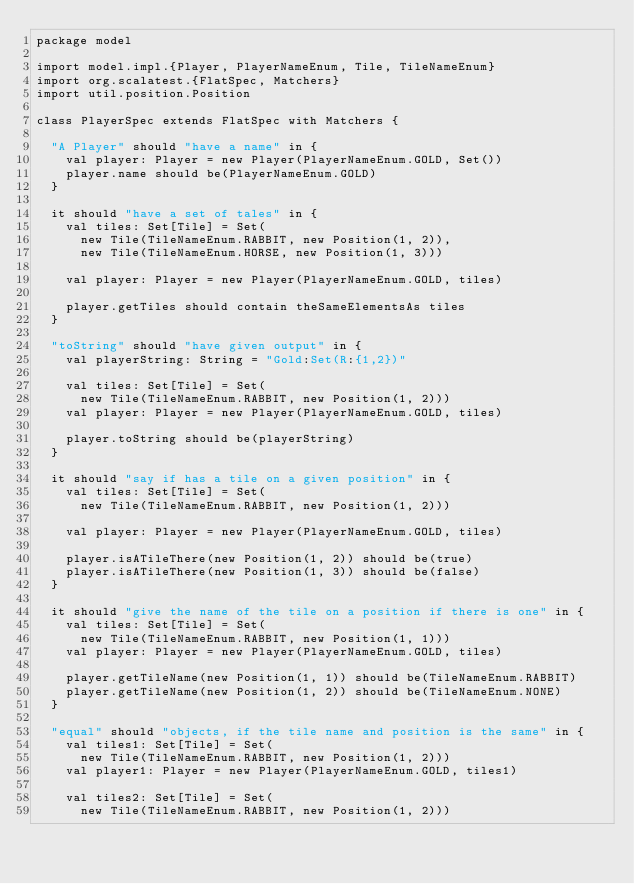Convert code to text. <code><loc_0><loc_0><loc_500><loc_500><_Scala_>package model

import model.impl.{Player, PlayerNameEnum, Tile, TileNameEnum}
import org.scalatest.{FlatSpec, Matchers}
import util.position.Position

class PlayerSpec extends FlatSpec with Matchers {

  "A Player" should "have a name" in {
    val player: Player = new Player(PlayerNameEnum.GOLD, Set())
    player.name should be(PlayerNameEnum.GOLD)
  }

  it should "have a set of tales" in {
    val tiles: Set[Tile] = Set(
      new Tile(TileNameEnum.RABBIT, new Position(1, 2)),
      new Tile(TileNameEnum.HORSE, new Position(1, 3)))

    val player: Player = new Player(PlayerNameEnum.GOLD, tiles)

    player.getTiles should contain theSameElementsAs tiles
  }

  "toString" should "have given output" in {
    val playerString: String = "Gold:Set(R:{1,2})"

    val tiles: Set[Tile] = Set(
      new Tile(TileNameEnum.RABBIT, new Position(1, 2)))
    val player: Player = new Player(PlayerNameEnum.GOLD, tiles)

    player.toString should be(playerString)
  }

  it should "say if has a tile on a given position" in {
    val tiles: Set[Tile] = Set(
      new Tile(TileNameEnum.RABBIT, new Position(1, 2)))

    val player: Player = new Player(PlayerNameEnum.GOLD, tiles)

    player.isATileThere(new Position(1, 2)) should be(true)
    player.isATileThere(new Position(1, 3)) should be(false)
  }

  it should "give the name of the tile on a position if there is one" in {
    val tiles: Set[Tile] = Set(
      new Tile(TileNameEnum.RABBIT, new Position(1, 1)))
    val player: Player = new Player(PlayerNameEnum.GOLD, tiles)

    player.getTileName(new Position(1, 1)) should be(TileNameEnum.RABBIT)
    player.getTileName(new Position(1, 2)) should be(TileNameEnum.NONE)
  }

  "equal" should "objects, if the tile name and position is the same" in {
    val tiles1: Set[Tile] = Set(
      new Tile(TileNameEnum.RABBIT, new Position(1, 2)))
    val player1: Player = new Player(PlayerNameEnum.GOLD, tiles1)

    val tiles2: Set[Tile] = Set(
      new Tile(TileNameEnum.RABBIT, new Position(1, 2)))</code> 